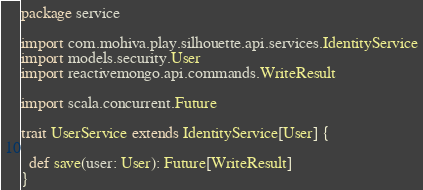<code> <loc_0><loc_0><loc_500><loc_500><_Scala_>package service

import com.mohiva.play.silhouette.api.services.IdentityService
import models.security.User
import reactivemongo.api.commands.WriteResult

import scala.concurrent.Future

trait UserService extends IdentityService[User] {

  def save(user: User): Future[WriteResult]
}
</code> 